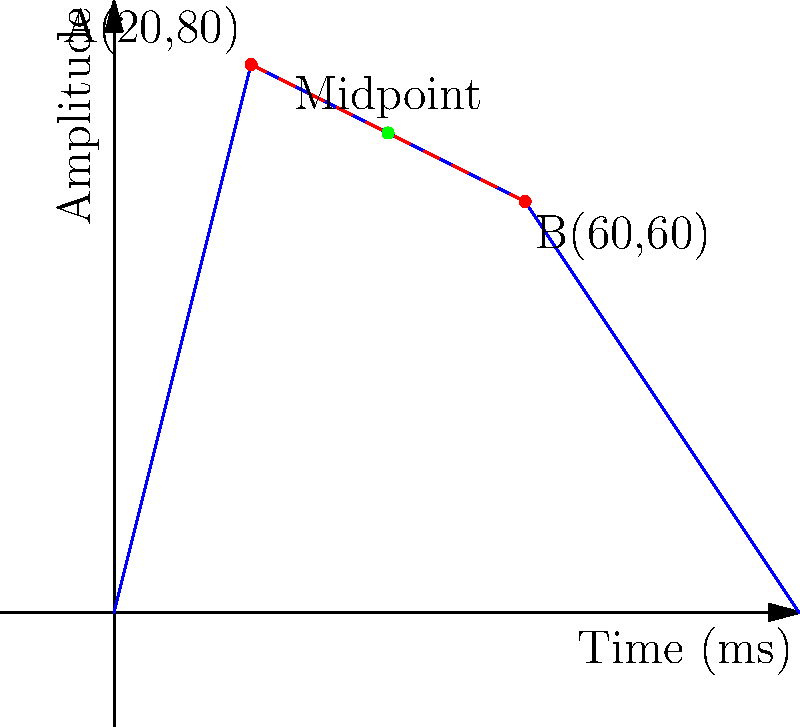In the ADSR envelope of a synthesizer, two control points A(20,80) and B(60,60) are connected by a line segment. Find the coordinates of the midpoint of this line segment. How might this midpoint be useful in envelope design? To find the midpoint of a line segment connecting two points, we use the midpoint formula:

$$ \text{Midpoint} = \left(\frac{x_1 + x_2}{2}, \frac{y_1 + y_2}{2}\right) $$

Where $(x_1, y_1)$ are the coordinates of point A, and $(x_2, y_2)$ are the coordinates of point B.

Step 1: Identify the coordinates
Point A: (20, 80)
Point B: (60, 60)

Step 2: Apply the midpoint formula
$$ x = \frac{20 + 60}{2} = \frac{80}{2} = 40 $$
$$ y = \frac{80 + 60}{2} = \frac{140}{2} = 70 $$

Therefore, the midpoint coordinates are (40, 70).

In envelope design, this midpoint could be useful for:
1. Creating more complex envelope shapes by adding additional control points.
2. Adjusting the curve's behavior between two existing control points.
3. Ensuring symmetry in certain parts of the envelope.
4. Fine-tuning the transition between different stages of the envelope (e.g., between attack and decay).
Answer: (40, 70) 